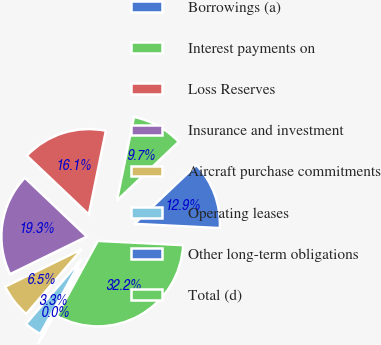Convert chart to OTSL. <chart><loc_0><loc_0><loc_500><loc_500><pie_chart><fcel>Borrowings (a)<fcel>Interest payments on<fcel>Loss Reserves<fcel>Insurance and investment<fcel>Aircraft purchase commitments<fcel>Operating leases<fcel>Other long-term obligations<fcel>Total (d)<nl><fcel>12.9%<fcel>9.69%<fcel>16.12%<fcel>19.33%<fcel>6.47%<fcel>3.26%<fcel>0.04%<fcel>32.19%<nl></chart> 